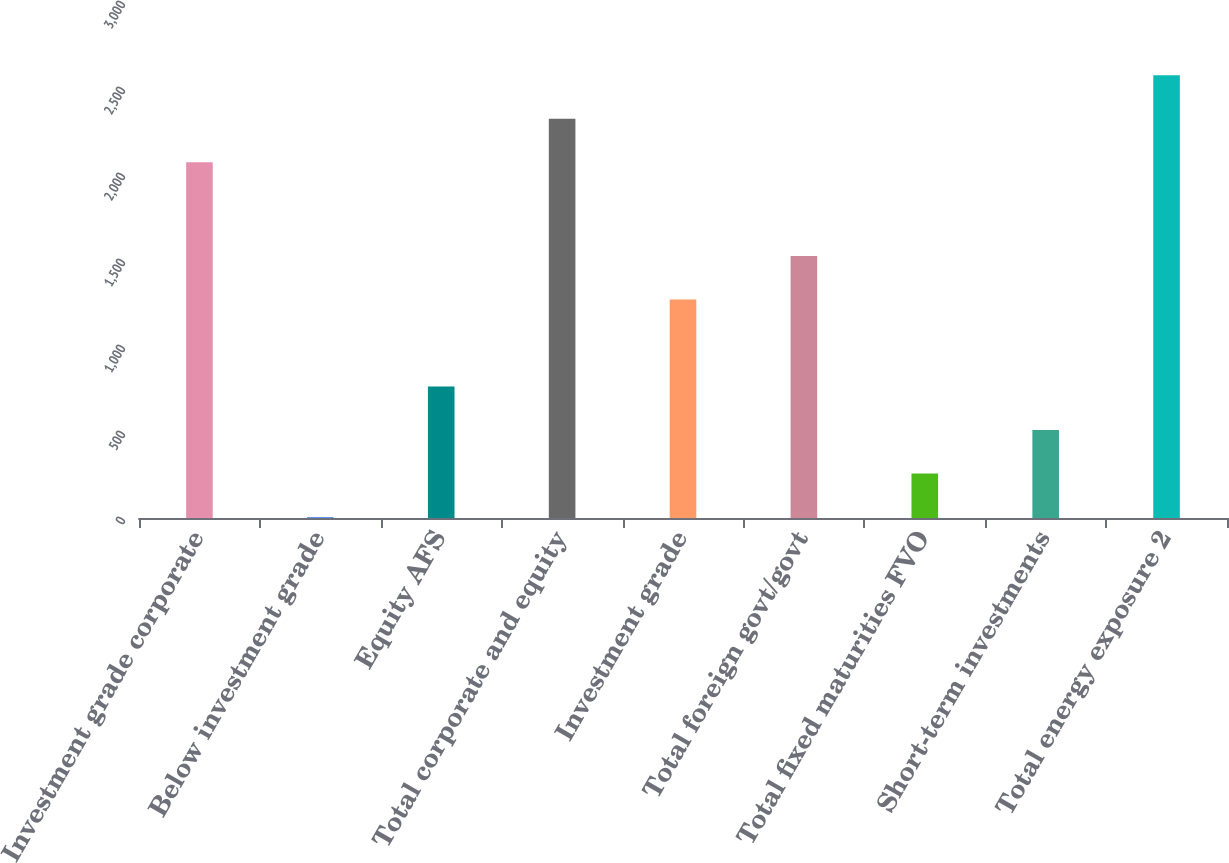Convert chart to OTSL. <chart><loc_0><loc_0><loc_500><loc_500><bar_chart><fcel>Investment grade corporate<fcel>Below investment grade<fcel>Equity AFS<fcel>Total corporate and equity<fcel>Investment grade<fcel>Total foreign govt/govt<fcel>Total fixed maturities FVO<fcel>Short-term investments<fcel>Total energy exposure 2<nl><fcel>2068<fcel>6<fcel>764.7<fcel>2320.9<fcel>1270.5<fcel>1523.4<fcel>258.9<fcel>511.8<fcel>2573.8<nl></chart> 